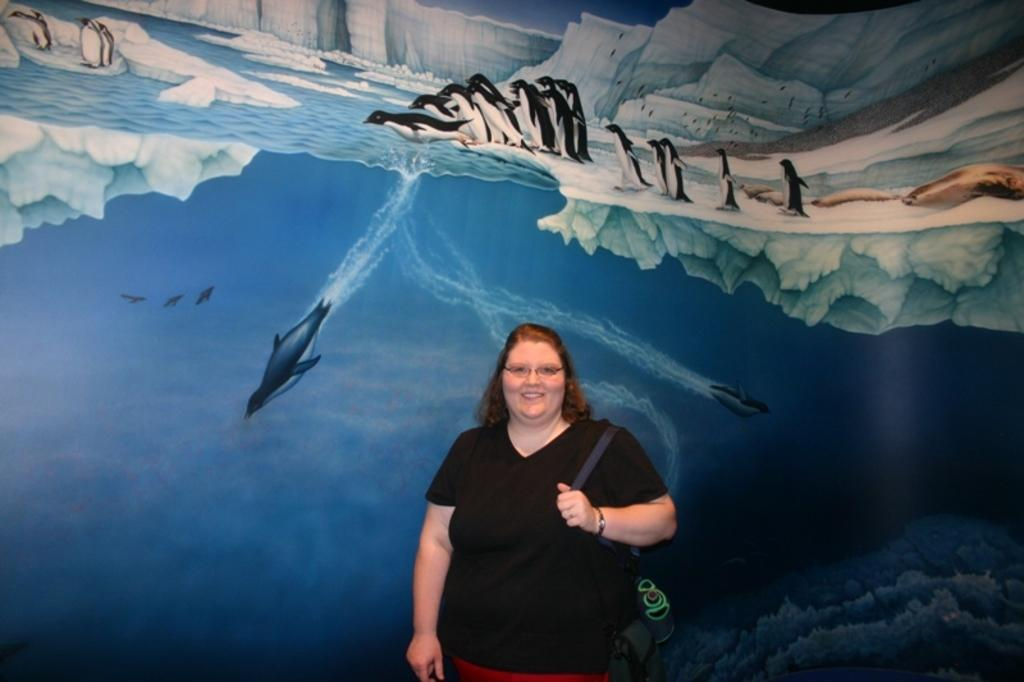What is the main subject of the image? The main subject of the image is a woman standing in the center. What is the woman wearing? The woman is wearing a bag. What is the woman's facial expression? The woman is smiling. What can be seen in the background of the image? There is a painting on the wall in the background. What type of finger food is being served at the event in the image? There is no event or finger food present in the image; it features a woman standing in the center with a painting on the wall in the background. 